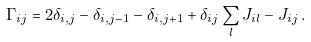Convert formula to latex. <formula><loc_0><loc_0><loc_500><loc_500>\Gamma _ { i j } = 2 \delta _ { i , j } - \delta _ { i , j - 1 } - \delta _ { i , j + 1 } + \delta _ { i j } \sum _ { l } J _ { i l } - J _ { i j } \, .</formula> 